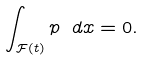Convert formula to latex. <formula><loc_0><loc_0><loc_500><loc_500>\int _ { \mathcal { F } ( t ) } p \ d x = 0 .</formula> 